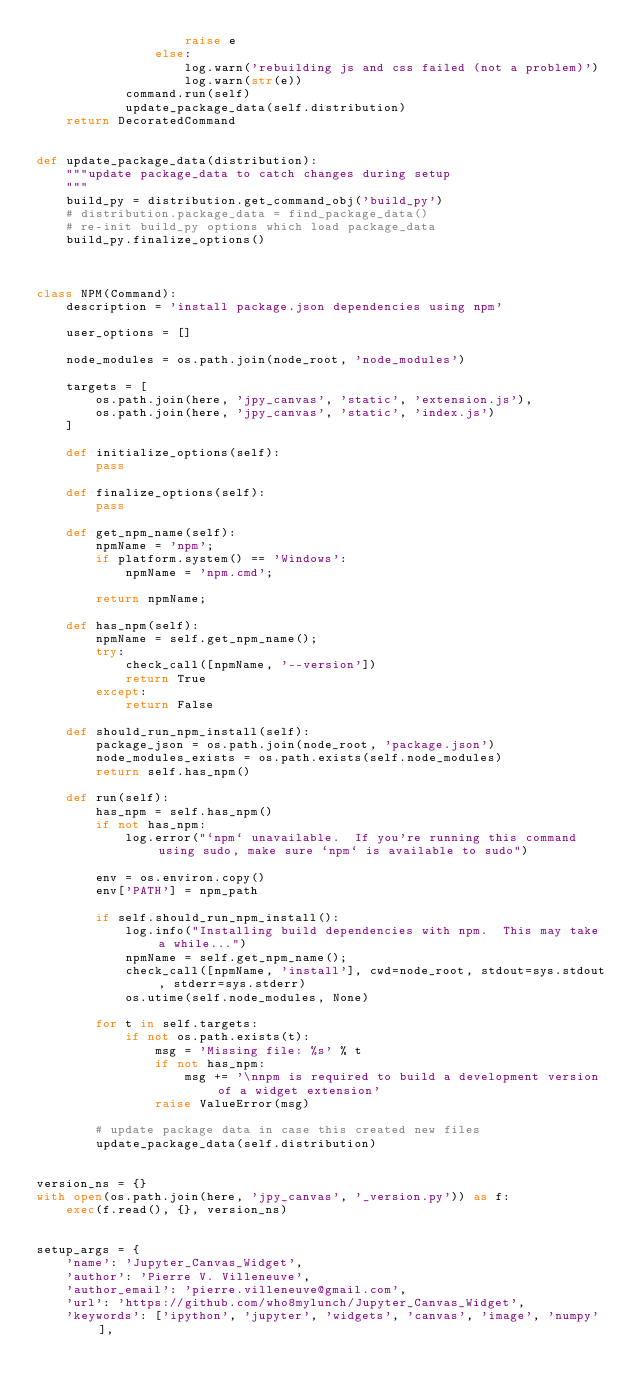<code> <loc_0><loc_0><loc_500><loc_500><_Python_>                    raise e
                else:
                    log.warn('rebuilding js and css failed (not a problem)')
                    log.warn(str(e))
            command.run(self)
            update_package_data(self.distribution)
    return DecoratedCommand


def update_package_data(distribution):
    """update package_data to catch changes during setup
    """
    build_py = distribution.get_command_obj('build_py')
    # distribution.package_data = find_package_data()
    # re-init build_py options which load package_data
    build_py.finalize_options()



class NPM(Command):
    description = 'install package.json dependencies using npm'

    user_options = []

    node_modules = os.path.join(node_root, 'node_modules')

    targets = [
        os.path.join(here, 'jpy_canvas', 'static', 'extension.js'),
        os.path.join(here, 'jpy_canvas', 'static', 'index.js')
    ]

    def initialize_options(self):
        pass

    def finalize_options(self):
        pass

    def get_npm_name(self):
        npmName = 'npm';
        if platform.system() == 'Windows':
            npmName = 'npm.cmd';

        return npmName;

    def has_npm(self):
        npmName = self.get_npm_name();
        try:
            check_call([npmName, '--version'])
            return True
        except:
            return False

    def should_run_npm_install(self):
        package_json = os.path.join(node_root, 'package.json')
        node_modules_exists = os.path.exists(self.node_modules)
        return self.has_npm()

    def run(self):
        has_npm = self.has_npm()
        if not has_npm:
            log.error("`npm` unavailable.  If you're running this command using sudo, make sure `npm` is available to sudo")

        env = os.environ.copy()
        env['PATH'] = npm_path

        if self.should_run_npm_install():
            log.info("Installing build dependencies with npm.  This may take a while...")
            npmName = self.get_npm_name();
            check_call([npmName, 'install'], cwd=node_root, stdout=sys.stdout, stderr=sys.stderr)
            os.utime(self.node_modules, None)

        for t in self.targets:
            if not os.path.exists(t):
                msg = 'Missing file: %s' % t
                if not has_npm:
                    msg += '\nnpm is required to build a development version of a widget extension'
                raise ValueError(msg)

        # update package data in case this created new files
        update_package_data(self.distribution)


version_ns = {}
with open(os.path.join(here, 'jpy_canvas', '_version.py')) as f:
    exec(f.read(), {}, version_ns)


setup_args = {
    'name': 'Jupyter_Canvas_Widget',
    'author': 'Pierre V. Villeneuve',
    'author_email': 'pierre.villeneuve@gmail.com',
    'url': 'https://github.com/who8mylunch/Jupyter_Canvas_Widget',
    'keywords': ['ipython', 'jupyter', 'widgets', 'canvas', 'image', 'numpy'],</code> 